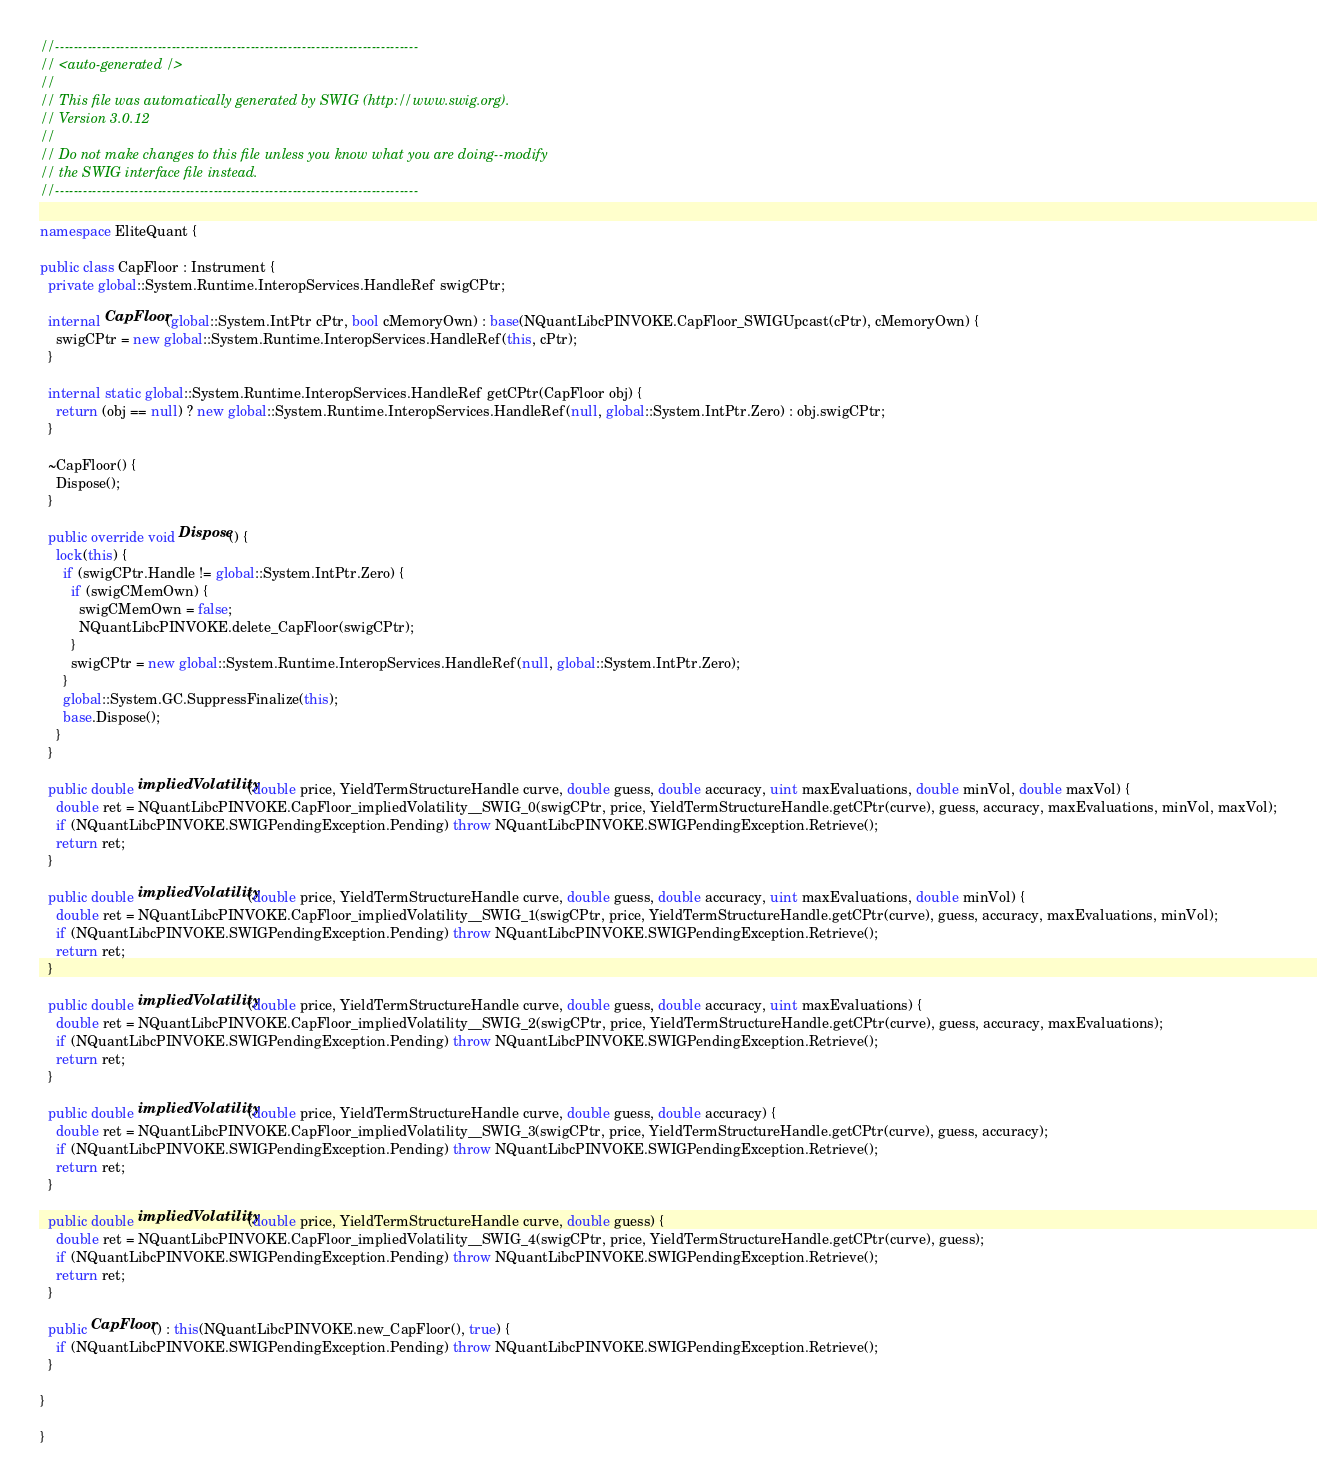Convert code to text. <code><loc_0><loc_0><loc_500><loc_500><_C#_>//------------------------------------------------------------------------------
// <auto-generated />
//
// This file was automatically generated by SWIG (http://www.swig.org).
// Version 3.0.12
//
// Do not make changes to this file unless you know what you are doing--modify
// the SWIG interface file instead.
//------------------------------------------------------------------------------

namespace EliteQuant {

public class CapFloor : Instrument {
  private global::System.Runtime.InteropServices.HandleRef swigCPtr;

  internal CapFloor(global::System.IntPtr cPtr, bool cMemoryOwn) : base(NQuantLibcPINVOKE.CapFloor_SWIGUpcast(cPtr), cMemoryOwn) {
    swigCPtr = new global::System.Runtime.InteropServices.HandleRef(this, cPtr);
  }

  internal static global::System.Runtime.InteropServices.HandleRef getCPtr(CapFloor obj) {
    return (obj == null) ? new global::System.Runtime.InteropServices.HandleRef(null, global::System.IntPtr.Zero) : obj.swigCPtr;
  }

  ~CapFloor() {
    Dispose();
  }

  public override void Dispose() {
    lock(this) {
      if (swigCPtr.Handle != global::System.IntPtr.Zero) {
        if (swigCMemOwn) {
          swigCMemOwn = false;
          NQuantLibcPINVOKE.delete_CapFloor(swigCPtr);
        }
        swigCPtr = new global::System.Runtime.InteropServices.HandleRef(null, global::System.IntPtr.Zero);
      }
      global::System.GC.SuppressFinalize(this);
      base.Dispose();
    }
  }

  public double impliedVolatility(double price, YieldTermStructureHandle curve, double guess, double accuracy, uint maxEvaluations, double minVol, double maxVol) {
    double ret = NQuantLibcPINVOKE.CapFloor_impliedVolatility__SWIG_0(swigCPtr, price, YieldTermStructureHandle.getCPtr(curve), guess, accuracy, maxEvaluations, minVol, maxVol);
    if (NQuantLibcPINVOKE.SWIGPendingException.Pending) throw NQuantLibcPINVOKE.SWIGPendingException.Retrieve();
    return ret;
  }

  public double impliedVolatility(double price, YieldTermStructureHandle curve, double guess, double accuracy, uint maxEvaluations, double minVol) {
    double ret = NQuantLibcPINVOKE.CapFloor_impliedVolatility__SWIG_1(swigCPtr, price, YieldTermStructureHandle.getCPtr(curve), guess, accuracy, maxEvaluations, minVol);
    if (NQuantLibcPINVOKE.SWIGPendingException.Pending) throw NQuantLibcPINVOKE.SWIGPendingException.Retrieve();
    return ret;
  }

  public double impliedVolatility(double price, YieldTermStructureHandle curve, double guess, double accuracy, uint maxEvaluations) {
    double ret = NQuantLibcPINVOKE.CapFloor_impliedVolatility__SWIG_2(swigCPtr, price, YieldTermStructureHandle.getCPtr(curve), guess, accuracy, maxEvaluations);
    if (NQuantLibcPINVOKE.SWIGPendingException.Pending) throw NQuantLibcPINVOKE.SWIGPendingException.Retrieve();
    return ret;
  }

  public double impliedVolatility(double price, YieldTermStructureHandle curve, double guess, double accuracy) {
    double ret = NQuantLibcPINVOKE.CapFloor_impliedVolatility__SWIG_3(swigCPtr, price, YieldTermStructureHandle.getCPtr(curve), guess, accuracy);
    if (NQuantLibcPINVOKE.SWIGPendingException.Pending) throw NQuantLibcPINVOKE.SWIGPendingException.Retrieve();
    return ret;
  }

  public double impliedVolatility(double price, YieldTermStructureHandle curve, double guess) {
    double ret = NQuantLibcPINVOKE.CapFloor_impliedVolatility__SWIG_4(swigCPtr, price, YieldTermStructureHandle.getCPtr(curve), guess);
    if (NQuantLibcPINVOKE.SWIGPendingException.Pending) throw NQuantLibcPINVOKE.SWIGPendingException.Retrieve();
    return ret;
  }

  public CapFloor() : this(NQuantLibcPINVOKE.new_CapFloor(), true) {
    if (NQuantLibcPINVOKE.SWIGPendingException.Pending) throw NQuantLibcPINVOKE.SWIGPendingException.Retrieve();
  }

}

}
</code> 